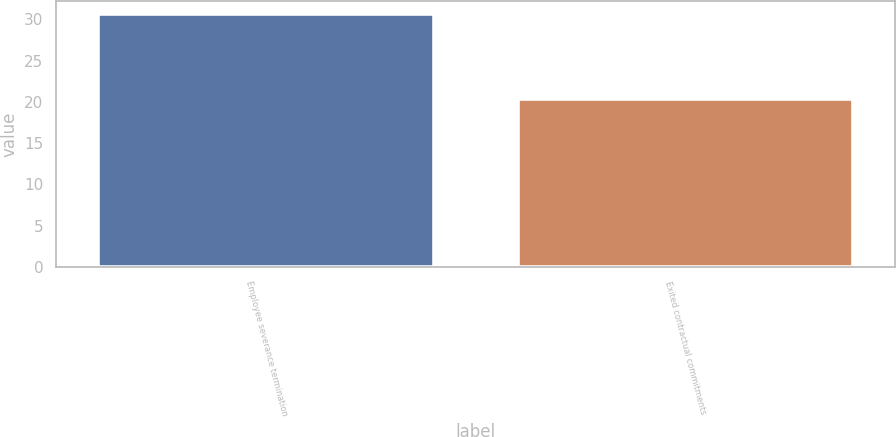Convert chart to OTSL. <chart><loc_0><loc_0><loc_500><loc_500><bar_chart><fcel>Employee severance termination<fcel>Exited contractual commitments<nl><fcel>30.7<fcel>20.3<nl></chart> 